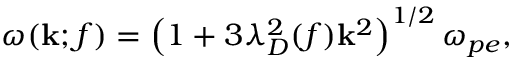Convert formula to latex. <formula><loc_0><loc_0><loc_500><loc_500>\omega ( k ; f ) = \left ( 1 + 3 \lambda _ { D } ^ { 2 } ( f ) k ^ { 2 } \right ) ^ { 1 / 2 } \omega _ { p e } ,</formula> 